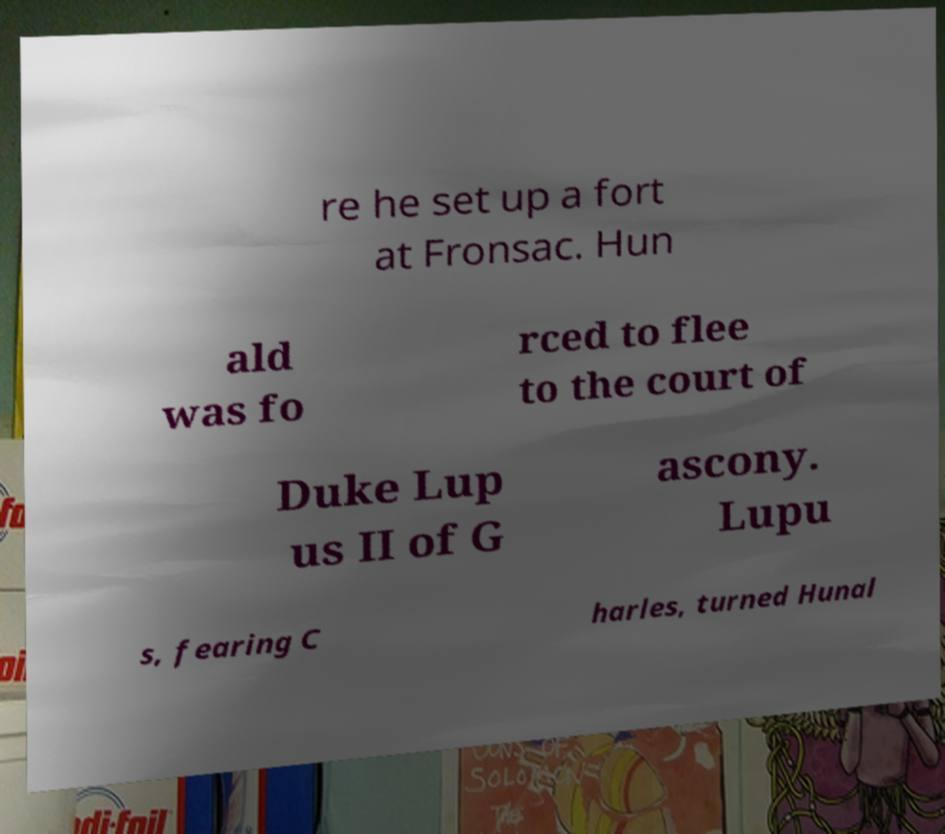What messages or text are displayed in this image? I need them in a readable, typed format. re he set up a fort at Fronsac. Hun ald was fo rced to flee to the court of Duke Lup us II of G ascony. Lupu s, fearing C harles, turned Hunal 